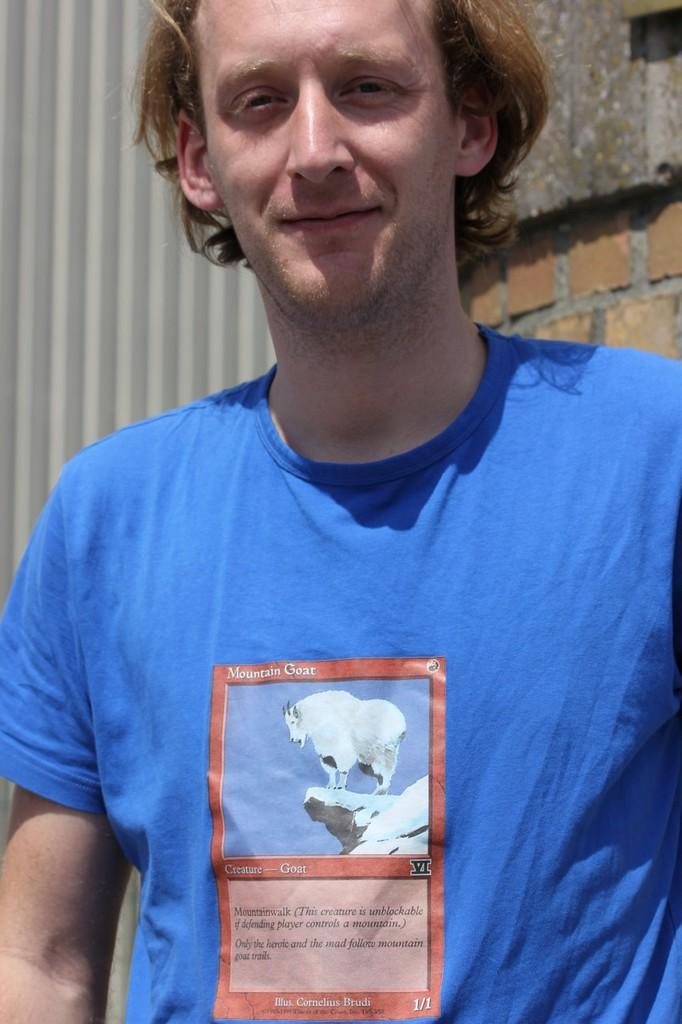Who or what is present in the image? There is a person in the image. What type of structure can be seen in the background? There is a brick wall in the image. What else is visible behind the person? There is a shed behind the person. How many rabbits are hopping around the person in the image? There are no rabbits present in the image. What type of ship can be seen sailing in the background of the image? There is no ship visible in the image; it features a person, a brick wall, and a shed. 